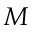<formula> <loc_0><loc_0><loc_500><loc_500>M</formula> 